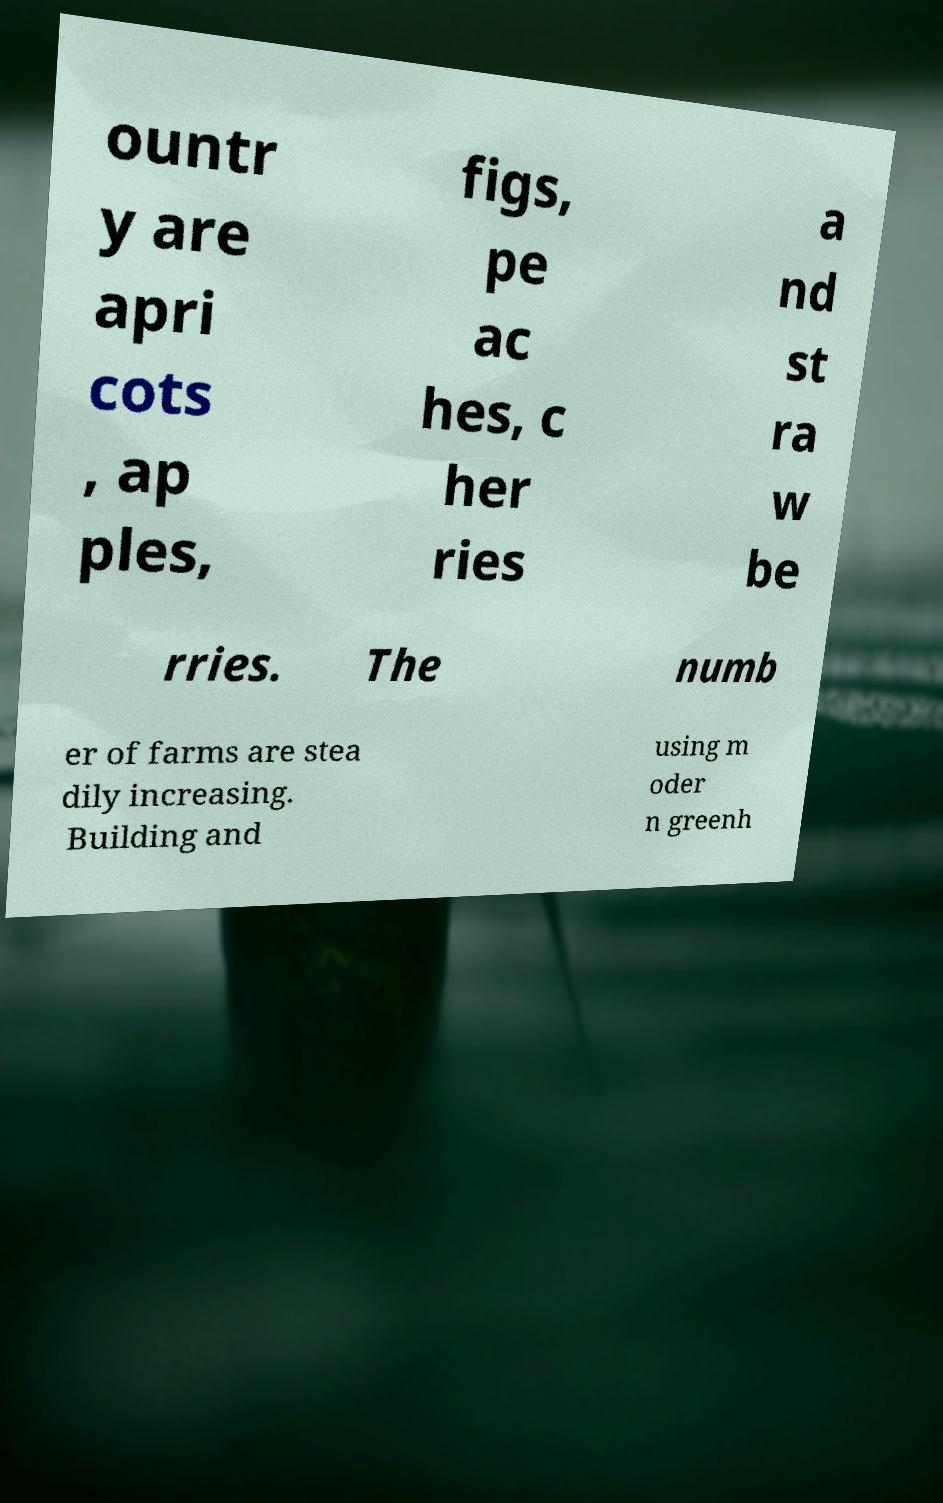Can you accurately transcribe the text from the provided image for me? ountr y are apri cots , ap ples, figs, pe ac hes, c her ries a nd st ra w be rries. The numb er of farms are stea dily increasing. Building and using m oder n greenh 